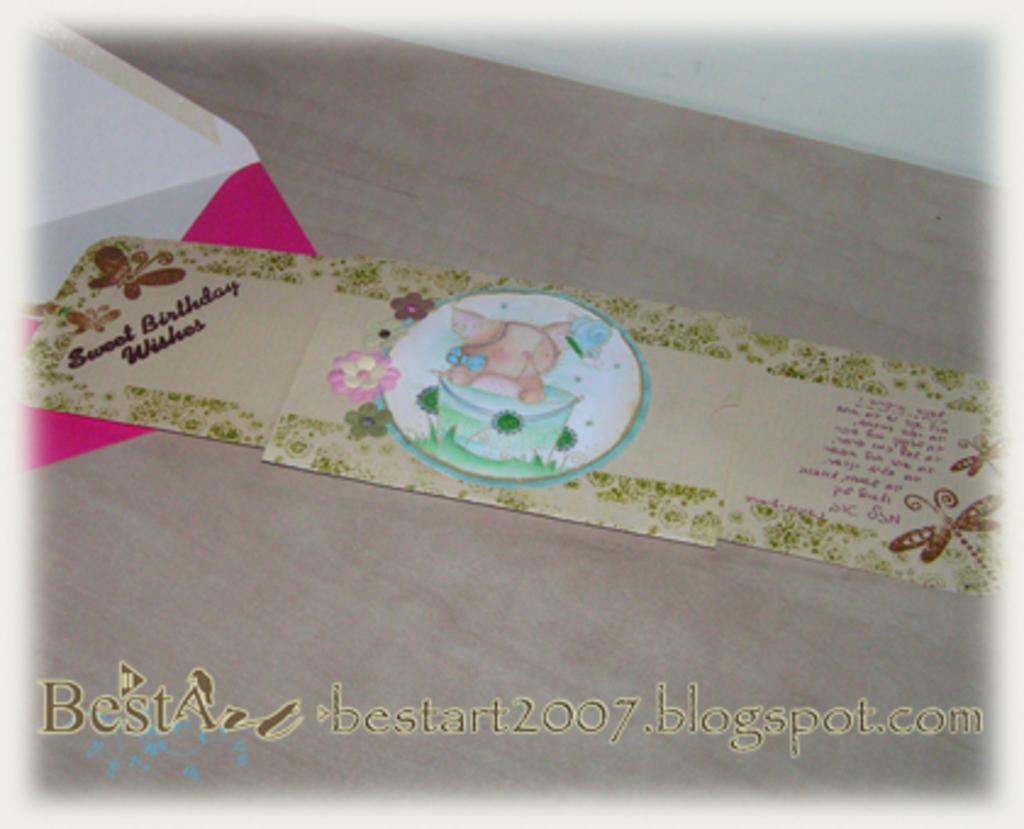Provide a one-sentence caption for the provided image. A thre panel card with drawing of a cat on birthday cake offering Sweet Birthday Wishes. 